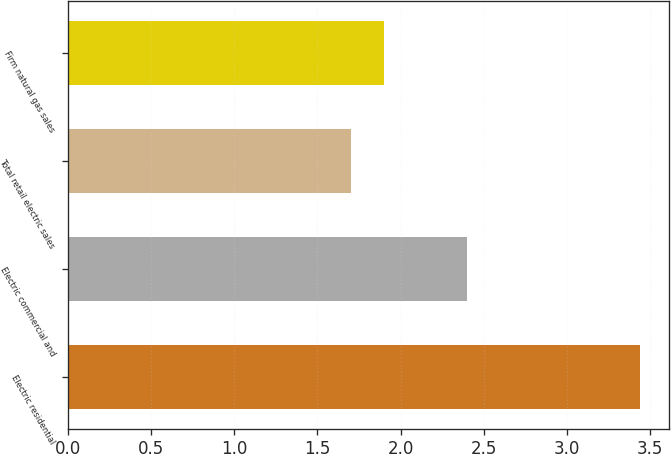Convert chart. <chart><loc_0><loc_0><loc_500><loc_500><bar_chart><fcel>Electric residential<fcel>Electric commercial and<fcel>Total retail electric sales<fcel>Firm natural gas sales<nl><fcel>3.44<fcel>2.4<fcel>1.7<fcel>1.9<nl></chart> 